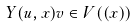Convert formula to latex. <formula><loc_0><loc_0><loc_500><loc_500>Y ( u , x ) v \in V ( ( x ) )</formula> 